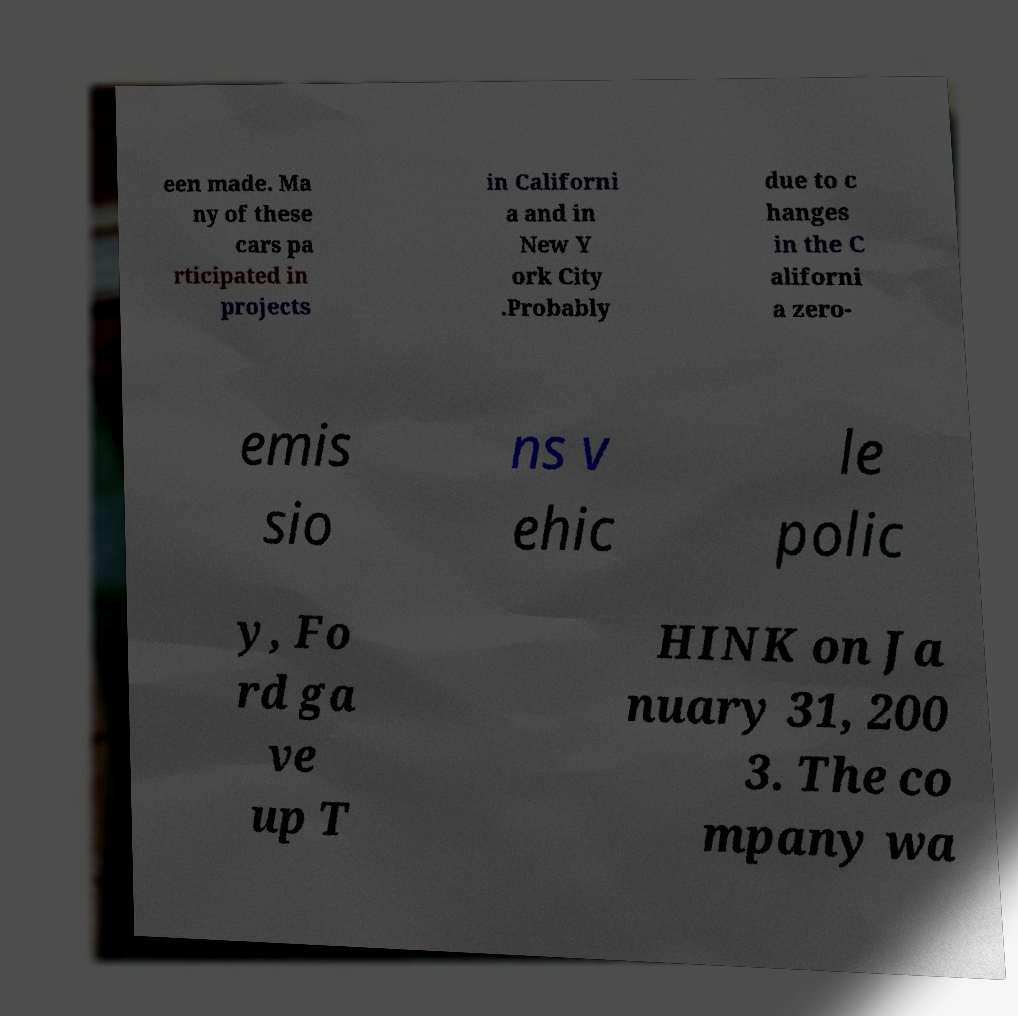I need the written content from this picture converted into text. Can you do that? een made. Ma ny of these cars pa rticipated in projects in Californi a and in New Y ork City .Probably due to c hanges in the C aliforni a zero- emis sio ns v ehic le polic y, Fo rd ga ve up T HINK on Ja nuary 31, 200 3. The co mpany wa 